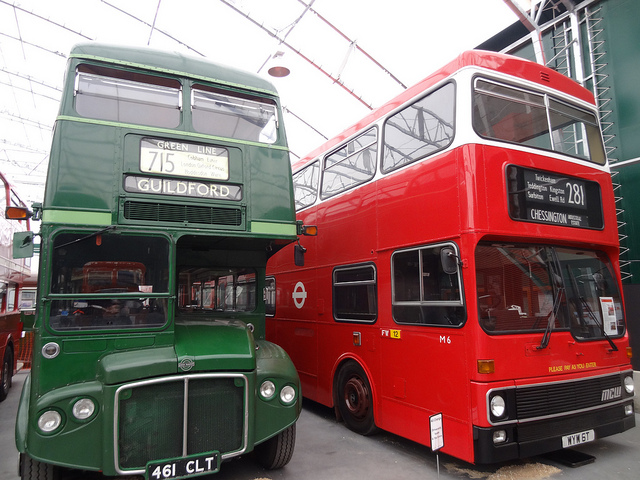<image>Does this bus support gay marriage? It's ambiguous if this bus supports gay marriage. Does this bus support gay marriage? I don't know if this bus supports gay marriage. It is unclear or uncertain based on the given information. 